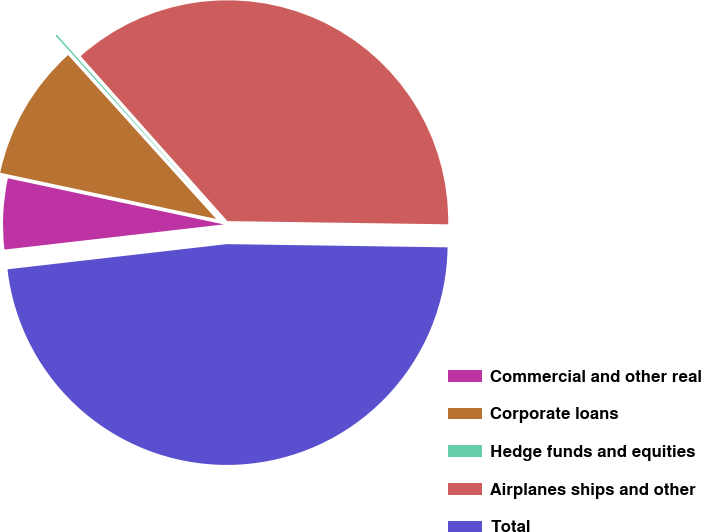Convert chart. <chart><loc_0><loc_0><loc_500><loc_500><pie_chart><fcel>Commercial and other real<fcel>Corporate loans<fcel>Hedge funds and equities<fcel>Airplanes ships and other<fcel>Total<nl><fcel>5.17%<fcel>9.96%<fcel>0.12%<fcel>36.8%<fcel>47.95%<nl></chart> 